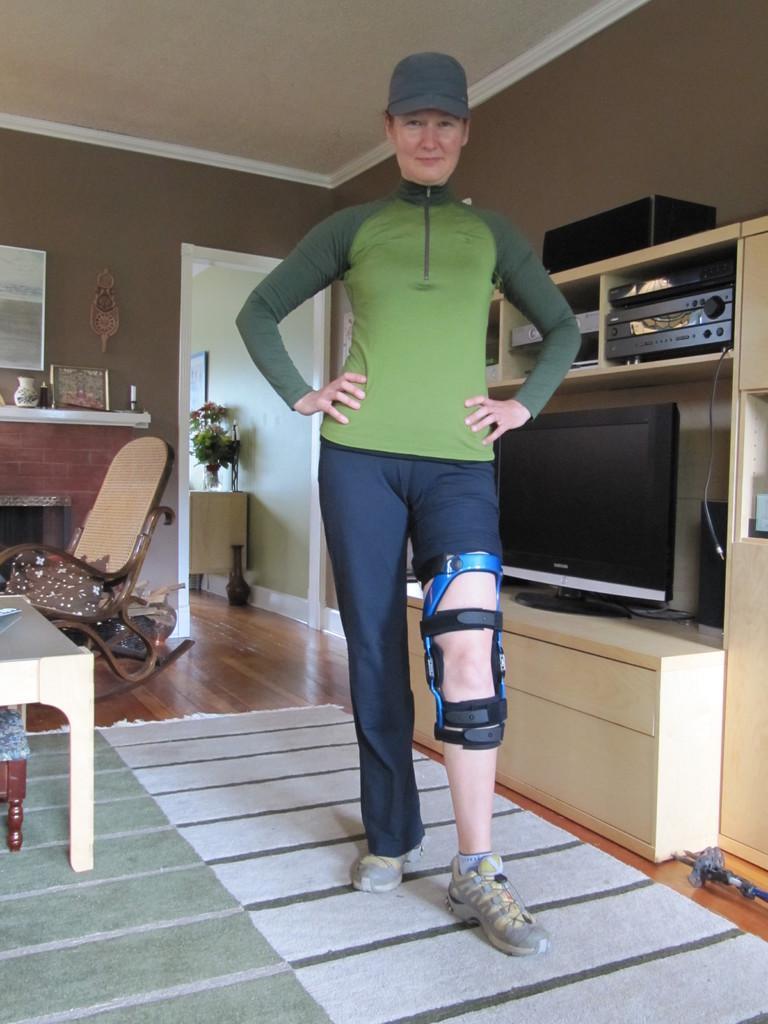How would you summarize this image in a sentence or two? There is a women standing and having a belt tightened to her one of her leg and there is a television and a home theater and a chair behind her. 